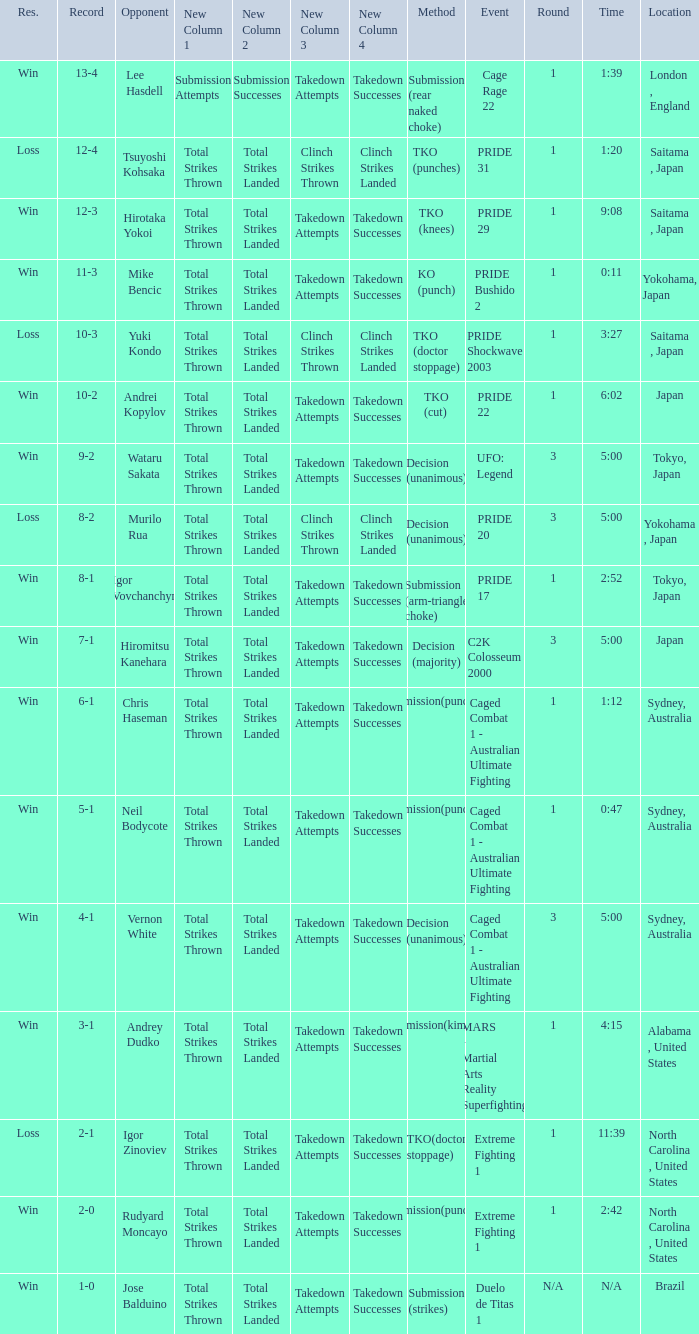Which Record has the Res of win with the Event of extreme fighting 1? 2-0. Can you give me this table as a dict? {'header': ['Res.', 'Record', 'Opponent', 'New Column 1', 'New Column 2', 'New Column 3', 'New Column 4', 'Method', 'Event', 'Round', 'Time', 'Location'], 'rows': [['Win', '13-4', 'Lee Hasdell', 'Submission Attempts', 'Submission Successes', 'Takedown Attempts', 'Takedown Successes', 'Submission (rear naked choke)', 'Cage Rage 22', '1', '1:39', 'London , England'], ['Loss', '12-4', 'Tsuyoshi Kohsaka', 'Total Strikes Thrown', 'Total Strikes Landed', 'Clinch Strikes Thrown', 'Clinch Strikes Landed', 'TKO (punches)', 'PRIDE 31', '1', '1:20', 'Saitama , Japan'], ['Win', '12-3', 'Hirotaka Yokoi', 'Total Strikes Thrown', 'Total Strikes Landed', 'Takedown Attempts', 'Takedown Successes', 'TKO (knees)', 'PRIDE 29', '1', '9:08', 'Saitama , Japan'], ['Win', '11-3', 'Mike Bencic', 'Total Strikes Thrown', 'Total Strikes Landed', 'Takedown Attempts', 'Takedown Successes', 'KO (punch)', 'PRIDE Bushido 2', '1', '0:11', 'Yokohama, Japan'], ['Loss', '10-3', 'Yuki Kondo', 'Total Strikes Thrown', 'Total Strikes Landed', 'Clinch Strikes Thrown', 'Clinch Strikes Landed', 'TKO (doctor stoppage)', 'PRIDE Shockwave 2003', '1', '3:27', 'Saitama , Japan'], ['Win', '10-2', 'Andrei Kopylov', 'Total Strikes Thrown', 'Total Strikes Landed', 'Takedown Attempts', 'Takedown Successes', 'TKO (cut)', 'PRIDE 22', '1', '6:02', 'Japan'], ['Win', '9-2', 'Wataru Sakata', 'Total Strikes Thrown', 'Total Strikes Landed', 'Takedown Attempts', 'Takedown Successes', 'Decision (unanimous)', 'UFO: Legend', '3', '5:00', 'Tokyo, Japan'], ['Loss', '8-2', 'Murilo Rua', 'Total Strikes Thrown', 'Total Strikes Landed', 'Clinch Strikes Thrown', 'Clinch Strikes Landed', 'Decision (unanimous)', 'PRIDE 20', '3', '5:00', 'Yokohama , Japan'], ['Win', '8-1', 'Igor Vovchanchyn', 'Total Strikes Thrown', 'Total Strikes Landed', 'Takedown Attempts', 'Takedown Successes', 'Submission (arm-triangle choke)', 'PRIDE 17', '1', '2:52', 'Tokyo, Japan'], ['Win', '7-1', 'Hiromitsu Kanehara', 'Total Strikes Thrown', 'Total Strikes Landed', 'Takedown Attempts', 'Takedown Successes', 'Decision (majority)', 'C2K Colosseum 2000', '3', '5:00', 'Japan'], ['Win', '6-1', 'Chris Haseman', 'Total Strikes Thrown', 'Total Strikes Landed', 'Takedown Attempts', 'Takedown Successes', 'Submission(punches)', 'Caged Combat 1 - Australian Ultimate Fighting', '1', '1:12', 'Sydney, Australia'], ['Win', '5-1', 'Neil Bodycote', 'Total Strikes Thrown', 'Total Strikes Landed', 'Takedown Attempts', 'Takedown Successes', 'Submission(punches)', 'Caged Combat 1 - Australian Ultimate Fighting', '1', '0:47', 'Sydney, Australia'], ['Win', '4-1', 'Vernon White', 'Total Strikes Thrown', 'Total Strikes Landed', 'Takedown Attempts', 'Takedown Successes', 'Decision (unanimous)', 'Caged Combat 1 - Australian Ultimate Fighting', '3', '5:00', 'Sydney, Australia'], ['Win', '3-1', 'Andrey Dudko', 'Total Strikes Thrown', 'Total Strikes Landed', 'Takedown Attempts', 'Takedown Successes', 'Submission(kimura)', 'MARS - Martial Arts Reality Superfighting', '1', '4:15', 'Alabama , United States'], ['Loss', '2-1', 'Igor Zinoviev', 'Total Strikes Thrown', 'Total Strikes Landed', 'Takedown Attempts', 'Takedown Successes', 'TKO(doctor stoppage)', 'Extreme Fighting 1', '1', '11:39', 'North Carolina , United States'], ['Win', '2-0', 'Rudyard Moncayo', 'Total Strikes Thrown', 'Total Strikes Landed', 'Takedown Attempts', 'Takedown Successes', 'Submission(punches)', 'Extreme Fighting 1', '1', '2:42', 'North Carolina , United States'], ['Win', '1-0', 'Jose Balduino', 'Total Strikes Thrown', 'Total Strikes Landed', 'Takedown Attempts', 'Takedown Successes', 'Submission (strikes)', 'Duelo de Titas 1', 'N/A', 'N/A', 'Brazil']]} 